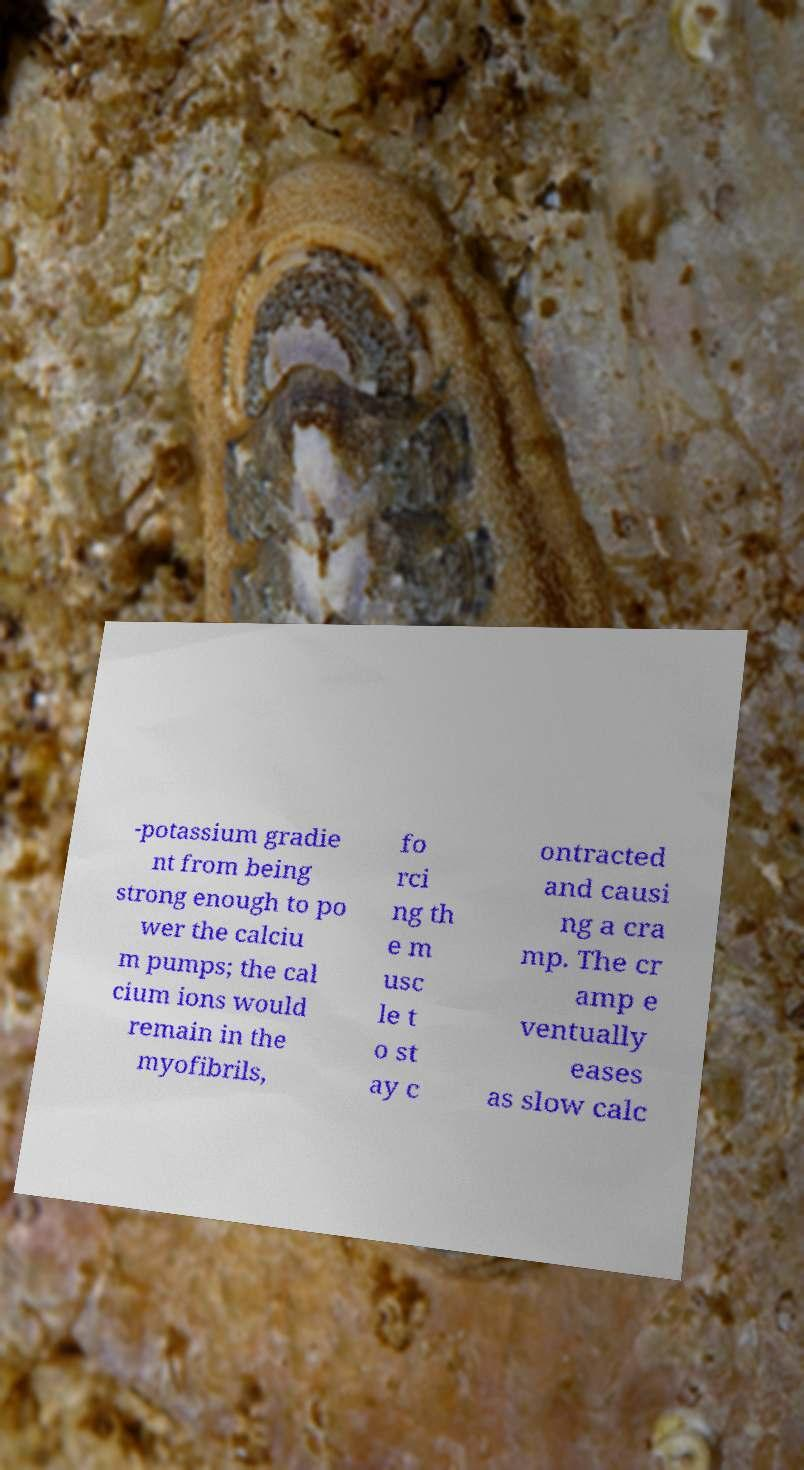Please read and relay the text visible in this image. What does it say? -potassium gradie nt from being strong enough to po wer the calciu m pumps; the cal cium ions would remain in the myofibrils, fo rci ng th e m usc le t o st ay c ontracted and causi ng a cra mp. The cr amp e ventually eases as slow calc 